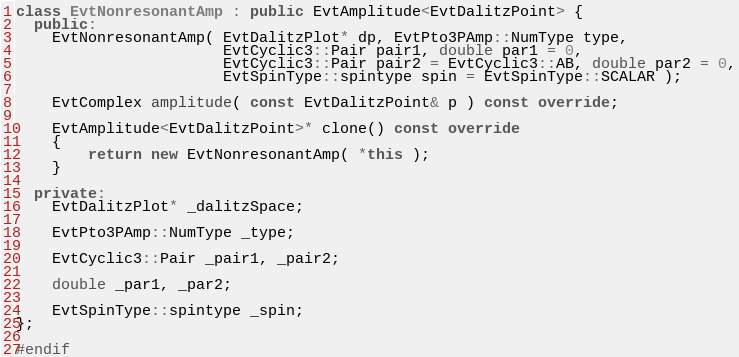<code> <loc_0><loc_0><loc_500><loc_500><_C++_>
class EvtNonresonantAmp : public EvtAmplitude<EvtDalitzPoint> {
  public:
    EvtNonresonantAmp( EvtDalitzPlot* dp, EvtPto3PAmp::NumType type,
                       EvtCyclic3::Pair pair1, double par1 = 0,
                       EvtCyclic3::Pair pair2 = EvtCyclic3::AB, double par2 = 0,
                       EvtSpinType::spintype spin = EvtSpinType::SCALAR );

    EvtComplex amplitude( const EvtDalitzPoint& p ) const override;

    EvtAmplitude<EvtDalitzPoint>* clone() const override
    {
        return new EvtNonresonantAmp( *this );
    }

  private:
    EvtDalitzPlot* _dalitzSpace;

    EvtPto3PAmp::NumType _type;

    EvtCyclic3::Pair _pair1, _pair2;

    double _par1, _par2;

    EvtSpinType::spintype _spin;
};

#endif
</code> 